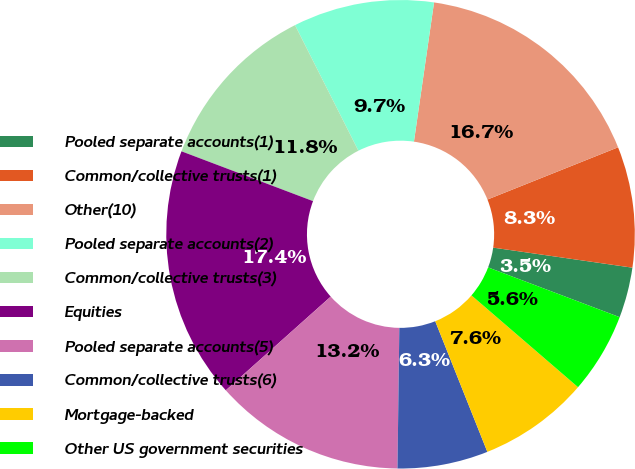Convert chart. <chart><loc_0><loc_0><loc_500><loc_500><pie_chart><fcel>Pooled separate accounts(1)<fcel>Common/collective trusts(1)<fcel>Other(10)<fcel>Pooled separate accounts(2)<fcel>Common/collective trusts(3)<fcel>Equities<fcel>Pooled separate accounts(5)<fcel>Common/collective trusts(6)<fcel>Mortgage-backed<fcel>Other US government securities<nl><fcel>3.48%<fcel>8.33%<fcel>16.66%<fcel>9.72%<fcel>11.8%<fcel>17.36%<fcel>13.19%<fcel>6.25%<fcel>7.64%<fcel>5.56%<nl></chart> 